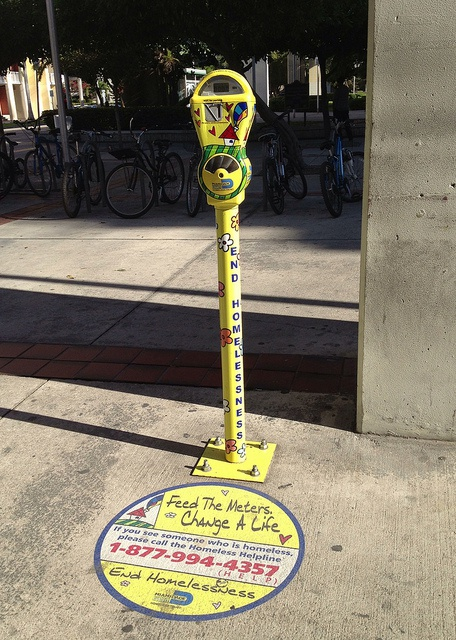Describe the objects in this image and their specific colors. I can see parking meter in black, yellow, olive, and khaki tones, bicycle in black and gray tones, bicycle in black, gray, and darkblue tones, bicycle in black, navy, gray, and darkblue tones, and bicycle in black and gray tones in this image. 